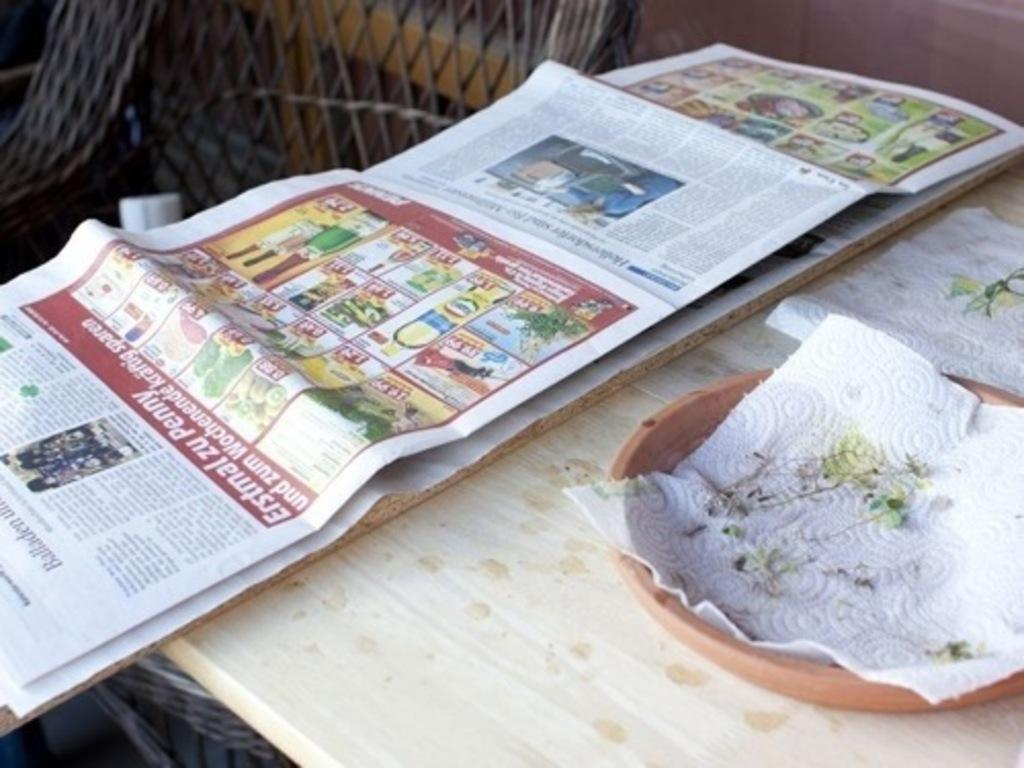What is one of the objects placed on the table in the image? There is a newspaper in the image. What else can be seen on the table in the image? There is a bowl and tissues placed on the table in the image. Can you describe the background of the image? There is a chair and a wall in the background of the image. What type of theory is being discussed in the image? There is no discussion or theory present in the image; it features a newspaper, bowl, tissues, a chair, and a wall. Can you see a knot tied on the newspaper in the image? There is no knot present on the newspaper or any other object in the image. 